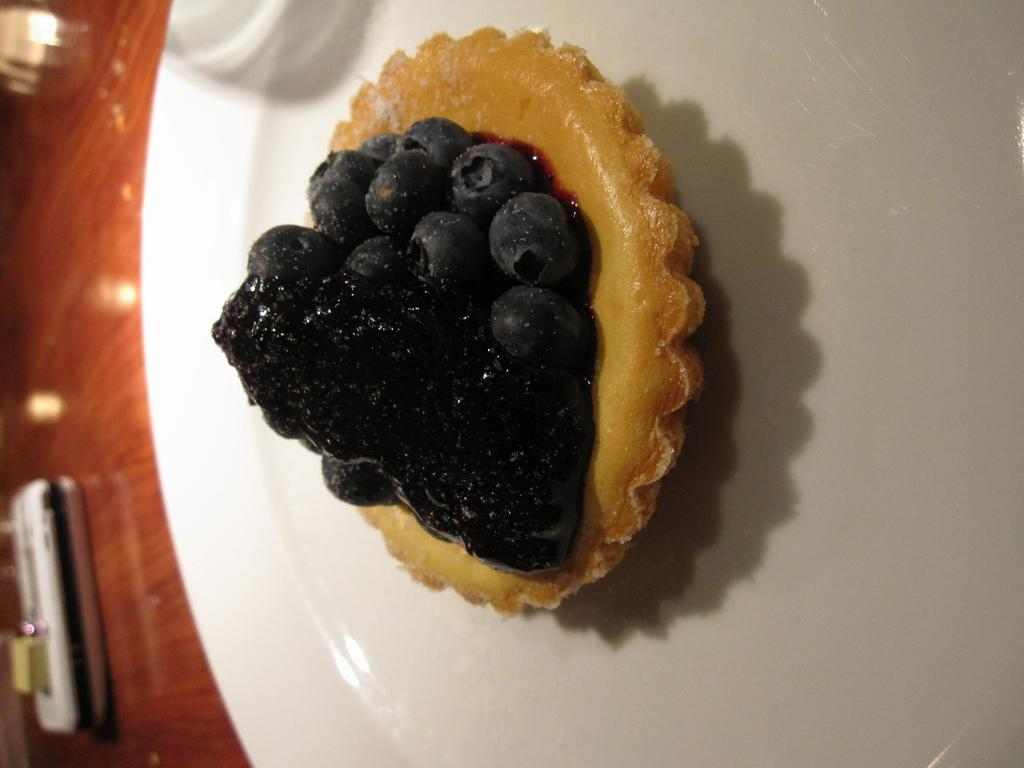What type of food can be seen in the image? The food in the image has black and brown colors. How is the food arranged in the image? The food is in a plate. What color is the plate? The plate is white in color. What is the surface beneath the plate? The plate is on a brown surface. What type of plants can be seen growing on the plate in the image? There are no plants visible on the plate in the image; it contains food with black and brown colors. 